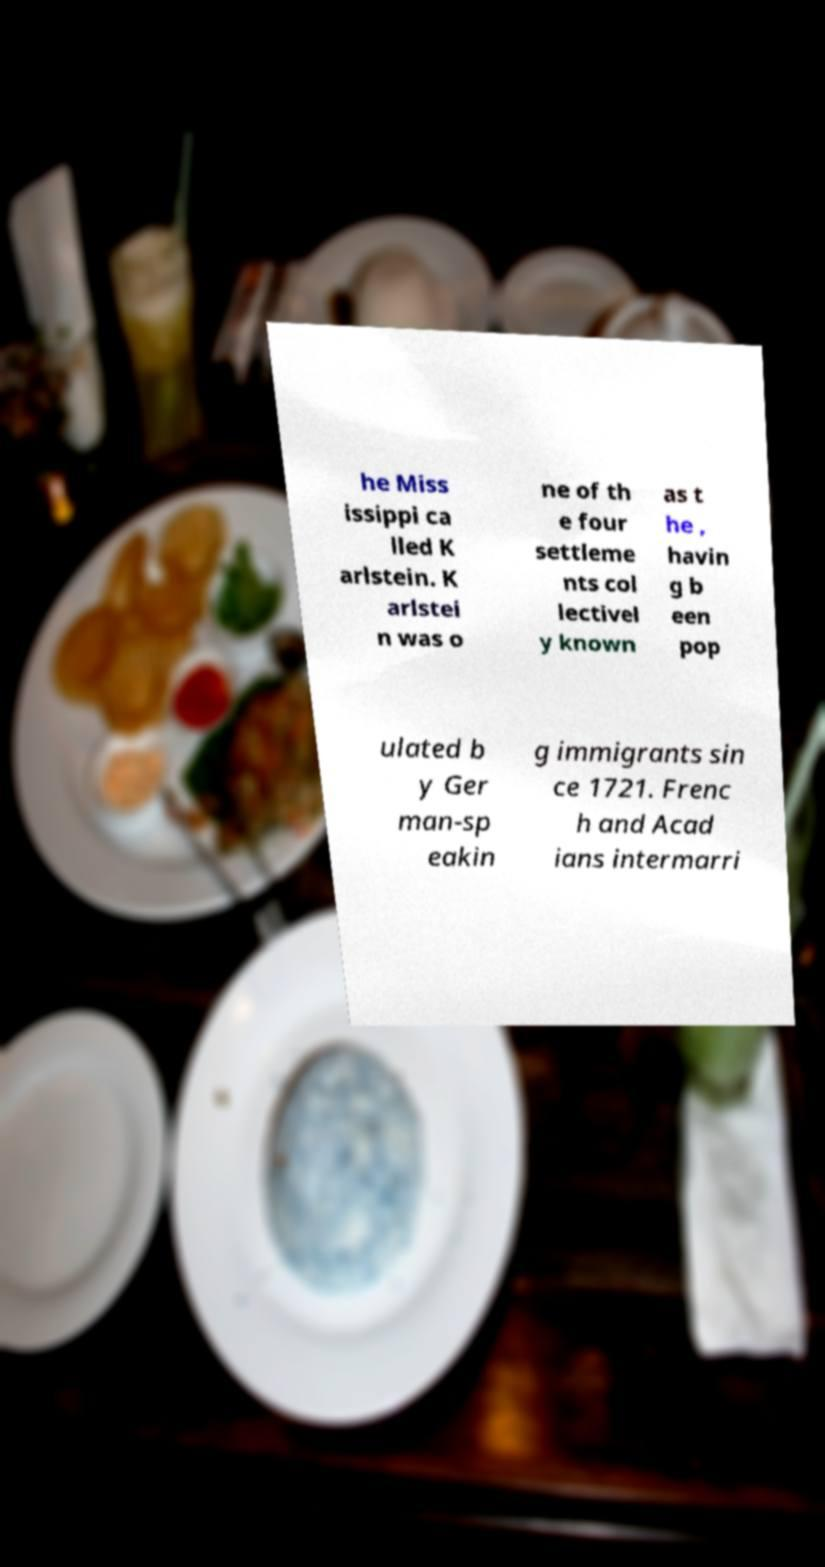Can you accurately transcribe the text from the provided image for me? he Miss issippi ca lled K arlstein. K arlstei n was o ne of th e four settleme nts col lectivel y known as t he , havin g b een pop ulated b y Ger man-sp eakin g immigrants sin ce 1721. Frenc h and Acad ians intermarri 